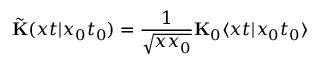<formula> <loc_0><loc_0><loc_500><loc_500>\tilde { K } ( x t | x _ { 0 } t _ { 0 } ) = \frac { 1 } { \sqrt { x x _ { 0 } } } { K } _ { 0 } \langle x t | x _ { 0 } t _ { 0 } \rangle</formula> 